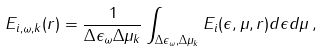Convert formula to latex. <formula><loc_0><loc_0><loc_500><loc_500>E _ { i , \omega , k } ( r ) = \frac { 1 } { \Delta \epsilon _ { \omega } \Delta \mu _ { k } } \int _ { \Delta \epsilon _ { \omega } , \Delta \mu _ { k } } E _ { i } ( \epsilon , \mu , r ) d \epsilon d \mu \, ,</formula> 